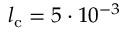Convert formula to latex. <formula><loc_0><loc_0><loc_500><loc_500>l _ { c } = 5 \cdot 1 0 ^ { - 3 }</formula> 